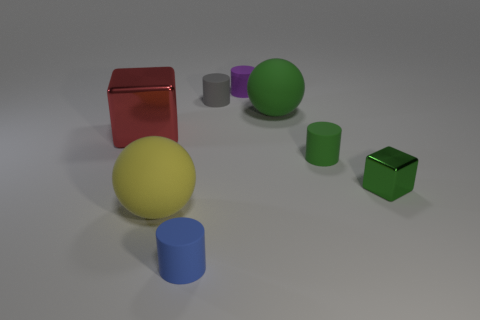Are the large green ball and the red object made of the same material?
Your response must be concise. No. Are there an equal number of green metallic cubes that are right of the big red metallic block and spheres left of the purple rubber cylinder?
Give a very brief answer. Yes. There is a green thing that is the same shape as the yellow object; what is its size?
Your answer should be very brief. Large. There is a large matte object that is to the left of the small blue matte thing; what shape is it?
Provide a succinct answer. Sphere. Is the cube that is left of the purple thing made of the same material as the green object that is in front of the tiny green cylinder?
Keep it short and to the point. Yes. What is the shape of the large yellow object?
Offer a very short reply. Sphere. Are there an equal number of big yellow spheres behind the yellow rubber sphere and gray things?
Your response must be concise. No. There is a ball that is the same color as the small metal object; what size is it?
Keep it short and to the point. Large. Is there a large yellow ball made of the same material as the gray cylinder?
Your response must be concise. Yes. Does the big yellow rubber thing that is to the left of the green matte cylinder have the same shape as the gray object to the left of the purple cylinder?
Your response must be concise. No. 